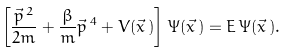<formula> <loc_0><loc_0><loc_500><loc_500>\left [ \frac { \vec { p } \, ^ { 2 } } { 2 m } + \frac { \beta } { m } \vec { p } \, ^ { 4 } + V ( \vec { x } \, ) \right ] \, \Psi ( \vec { x } \, ) = E \, \Psi ( \vec { x } \, ) .</formula> 